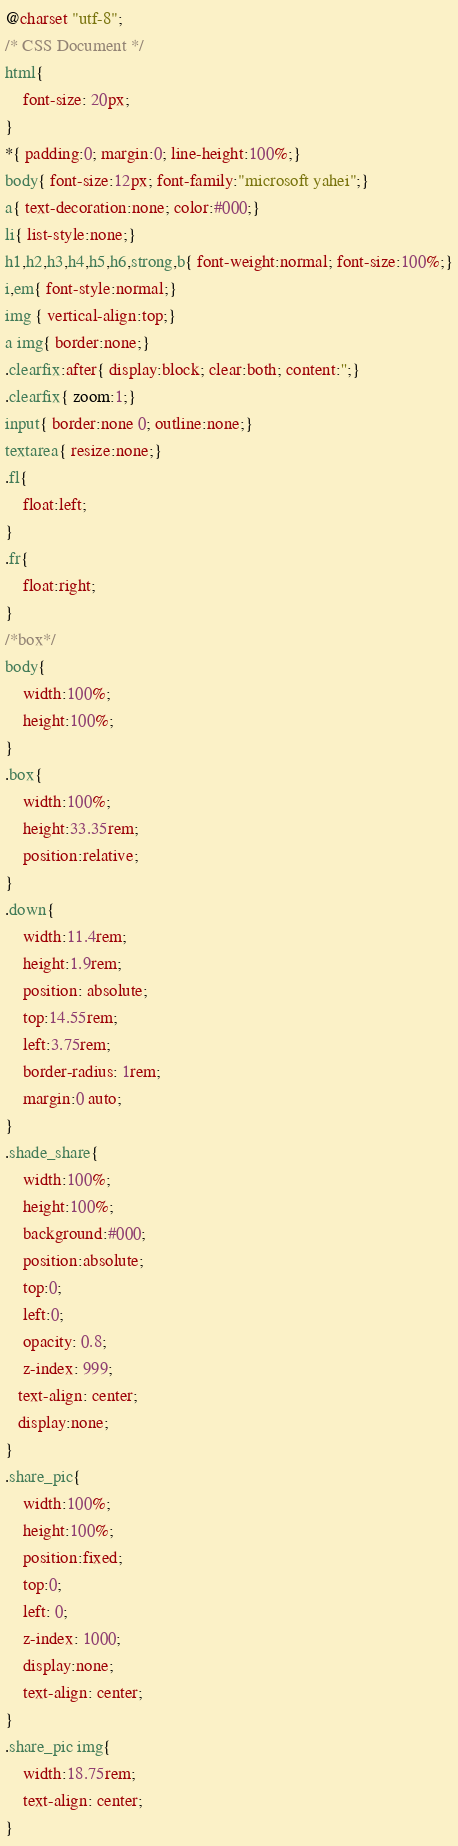Convert code to text. <code><loc_0><loc_0><loc_500><loc_500><_CSS_>@charset "utf-8";
/* CSS Document */
html{
    font-size: 20px;
}
*{ padding:0; margin:0; line-height:100%;}
body{ font-size:12px; font-family:"microsoft yahei";}
a{ text-decoration:none; color:#000;}
li{ list-style:none;}
h1,h2,h3,h4,h5,h6,strong,b{ font-weight:normal; font-size:100%;}
i,em{ font-style:normal;}
img { vertical-align:top;}
a img{ border:none;}
.clearfix:after{ display:block; clear:both; content:'';}
.clearfix{ zoom:1;}
input{ border:none 0; outline:none;}
textarea{ resize:none;}
.fl{
    float:left;
}
.fr{
    float:right;
}
/*box*/
body{
    width:100%;
    height:100%;
}
.box{
    width:100%;
    height:33.35rem;
    position:relative;
}
.down{
    width:11.4rem;
    height:1.9rem;
    position: absolute;
    top:14.55rem;
    left:3.75rem;
    border-radius: 1rem;
    margin:0 auto;
}
.shade_share{
    width:100%;
    height:100%;
    background:#000;
    position:absolute;
    top:0;
    left:0;
    opacity: 0.8;
    z-index: 999;
   text-align: center;
   display:none;
}
.share_pic{
    width:100%;
    height:100%;
    position:fixed;
    top:0;
    left: 0;
    z-index: 1000;
    display:none;
    text-align: center;
}
.share_pic img{
    width:18.75rem;
    text-align: center;
}</code> 